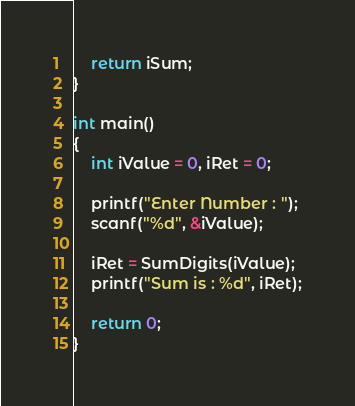<code> <loc_0><loc_0><loc_500><loc_500><_C_>    return iSum;
}

int main()
{
    int iValue = 0, iRet = 0;

    printf("Enter Number : ");
    scanf("%d", &iValue);

    iRet = SumDigits(iValue);
    printf("Sum is : %d", iRet);

    return 0;
}</code> 